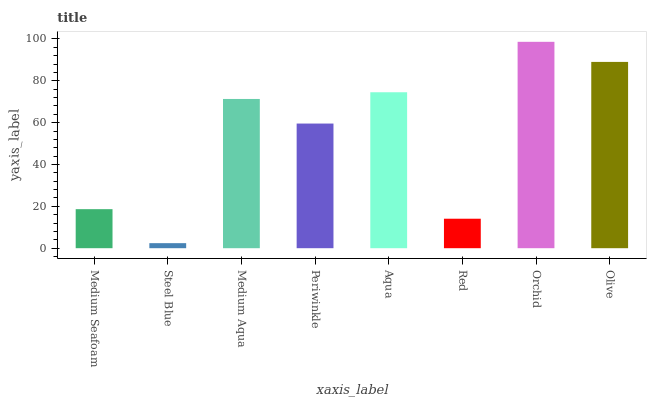Is Steel Blue the minimum?
Answer yes or no. Yes. Is Orchid the maximum?
Answer yes or no. Yes. Is Medium Aqua the minimum?
Answer yes or no. No. Is Medium Aqua the maximum?
Answer yes or no. No. Is Medium Aqua greater than Steel Blue?
Answer yes or no. Yes. Is Steel Blue less than Medium Aqua?
Answer yes or no. Yes. Is Steel Blue greater than Medium Aqua?
Answer yes or no. No. Is Medium Aqua less than Steel Blue?
Answer yes or no. No. Is Medium Aqua the high median?
Answer yes or no. Yes. Is Periwinkle the low median?
Answer yes or no. Yes. Is Orchid the high median?
Answer yes or no. No. Is Steel Blue the low median?
Answer yes or no. No. 